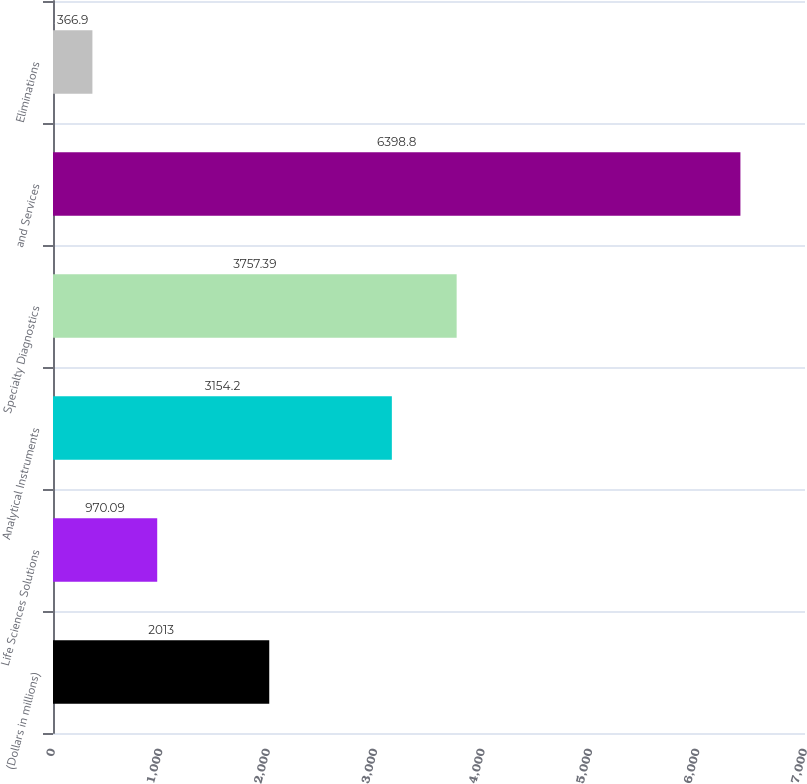Convert chart to OTSL. <chart><loc_0><loc_0><loc_500><loc_500><bar_chart><fcel>(Dollars in millions)<fcel>Life Sciences Solutions<fcel>Analytical Instruments<fcel>Specialty Diagnostics<fcel>and Services<fcel>Eliminations<nl><fcel>2013<fcel>970.09<fcel>3154.2<fcel>3757.39<fcel>6398.8<fcel>366.9<nl></chart> 